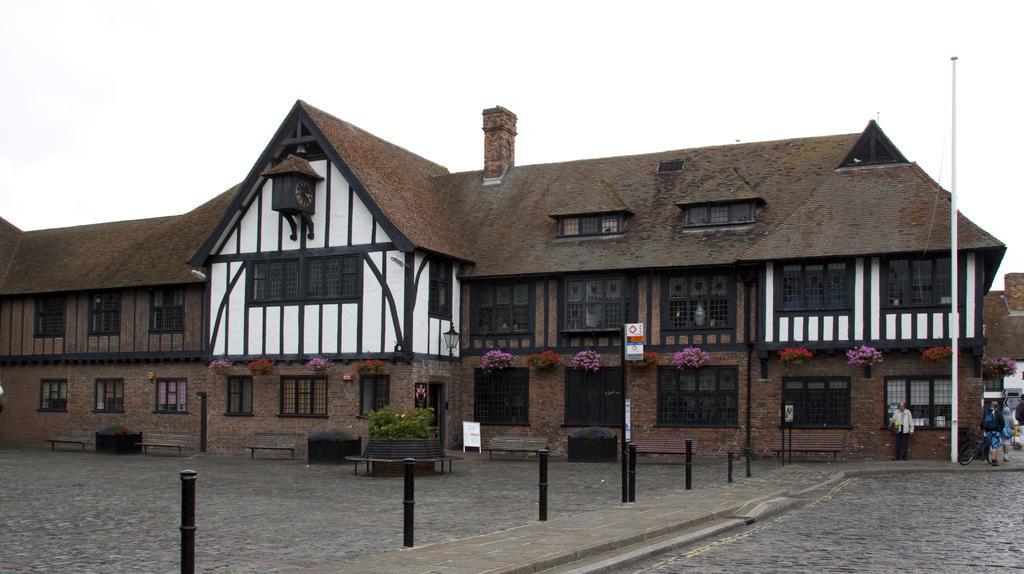Can you describe this image briefly? In this image in the center there is a building. In the front there are poles and on the right side of the building there are persons and the sky is cloudy and in front of the building there is a pole which is on the right side. 